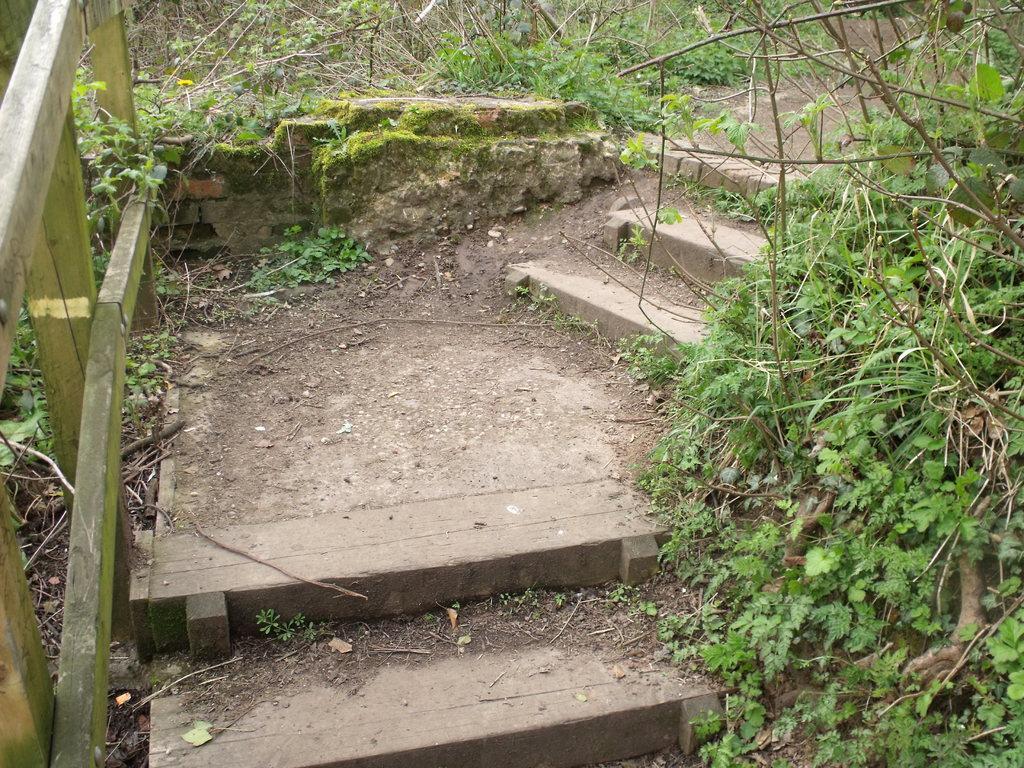Describe this image in one or two sentences. In this image I can see the stairs and on the both sides there are plants and sticks. On the left side there is a railing made up of wood. 